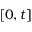Convert formula to latex. <formula><loc_0><loc_0><loc_500><loc_500>[ 0 , t ]</formula> 